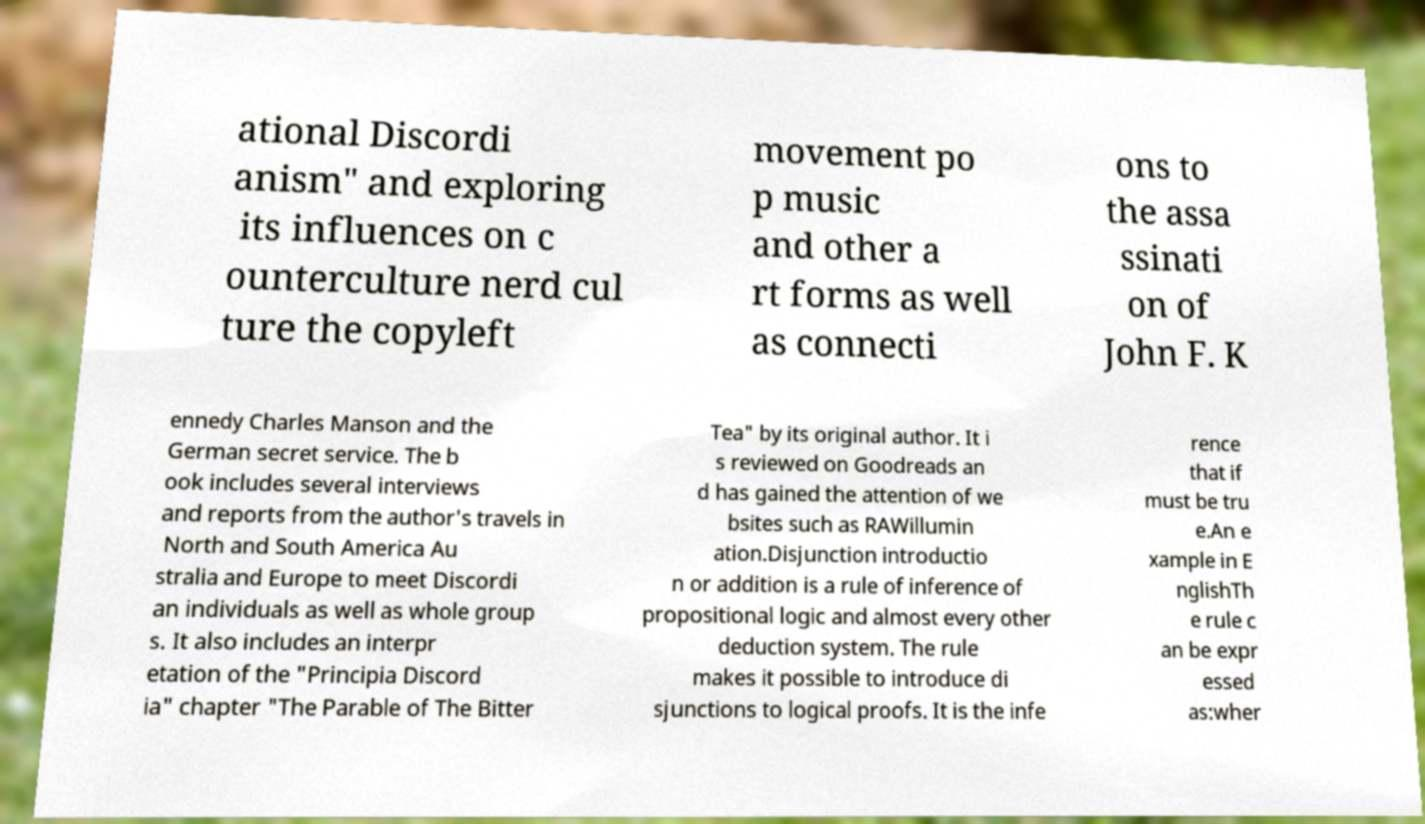Can you read and provide the text displayed in the image?This photo seems to have some interesting text. Can you extract and type it out for me? ational Discordi anism" and exploring its influences on c ounterculture nerd cul ture the copyleft movement po p music and other a rt forms as well as connecti ons to the assa ssinati on of John F. K ennedy Charles Manson and the German secret service. The b ook includes several interviews and reports from the author's travels in North and South America Au stralia and Europe to meet Discordi an individuals as well as whole group s. It also includes an interpr etation of the "Principia Discord ia" chapter "The Parable of The Bitter Tea" by its original author. It i s reviewed on Goodreads an d has gained the attention of we bsites such as RAWillumin ation.Disjunction introductio n or addition is a rule of inference of propositional logic and almost every other deduction system. The rule makes it possible to introduce di sjunctions to logical proofs. It is the infe rence that if must be tru e.An e xample in E nglishTh e rule c an be expr essed as:wher 